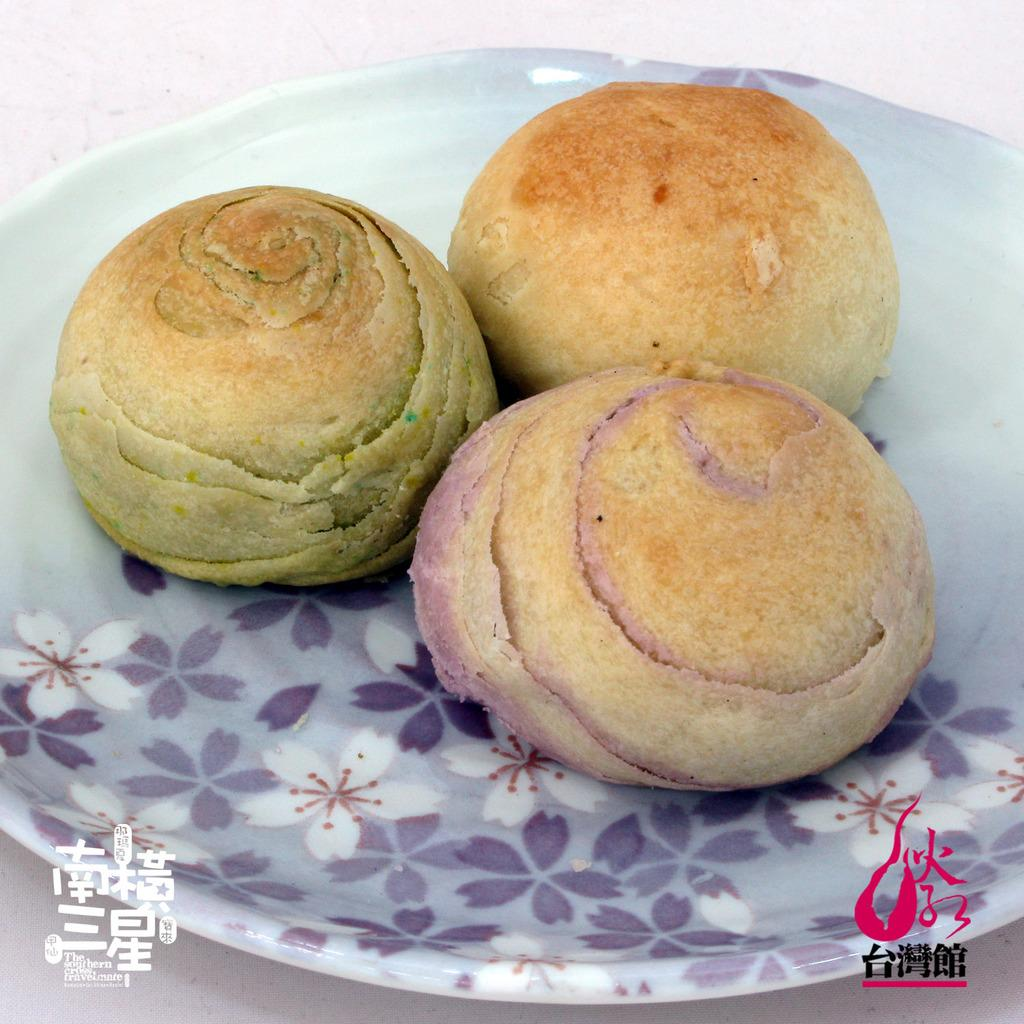What is the main subject of the image? The main subject of the image is a group of food items. How are the food items arranged in the image? The food items are placed on a plate. What type of giants can be seen walking through the sleet in the image? There are no giants or sleet present in the image; it features a group of food items placed on a plate. 